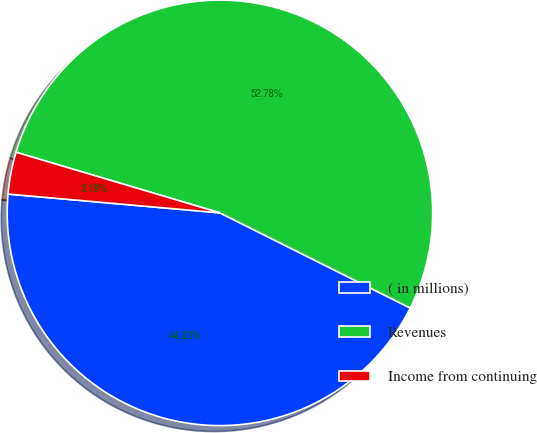Convert chart to OTSL. <chart><loc_0><loc_0><loc_500><loc_500><pie_chart><fcel>( in millions)<fcel>Revenues<fcel>Income from continuing<nl><fcel>44.03%<fcel>52.78%<fcel>3.19%<nl></chart> 